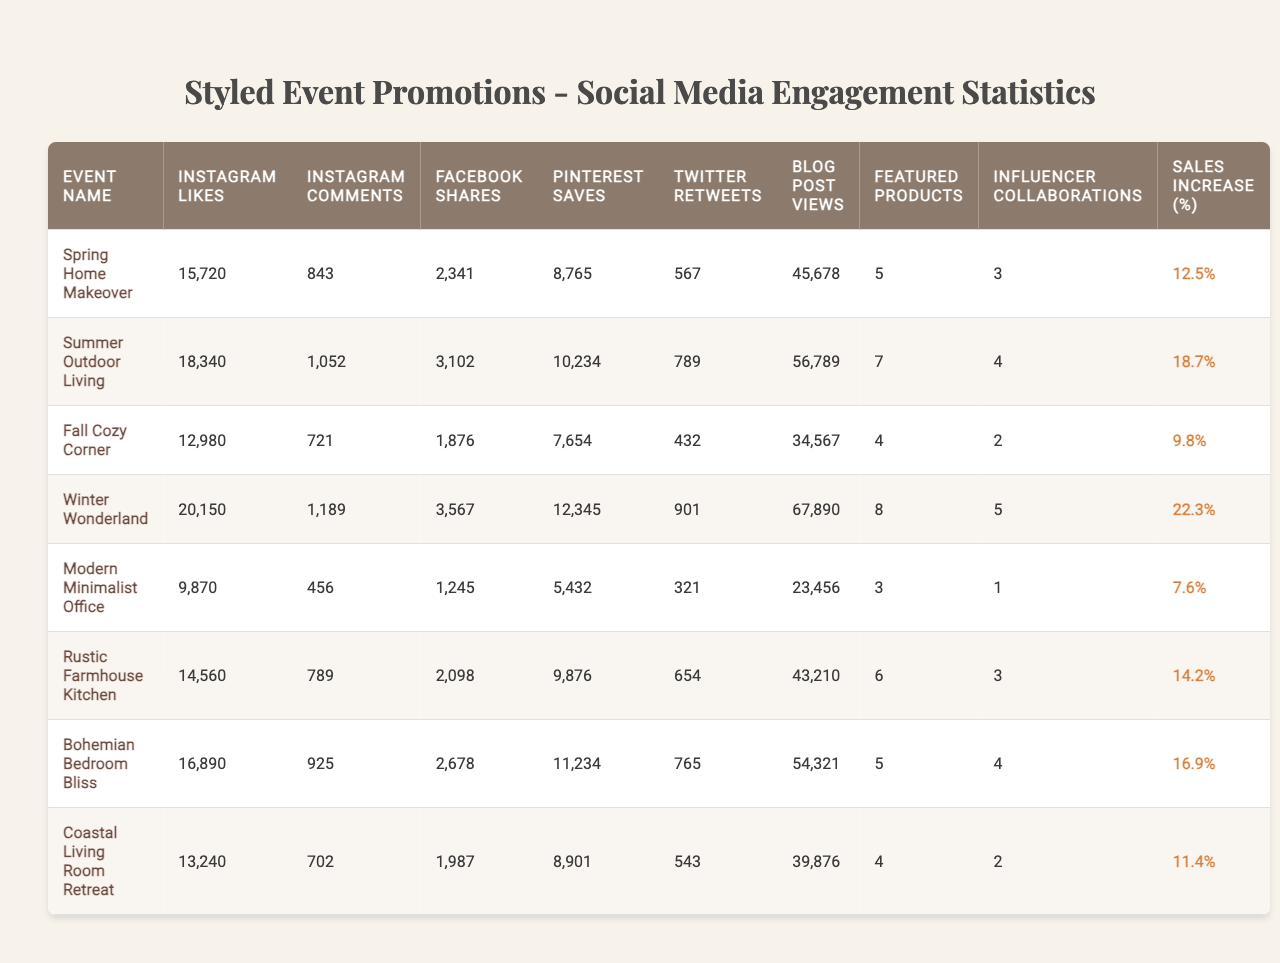What is the highest number of Instagram likes received for any event? Looking at the column for Instagram Likes, the highest value is 20150, which is for the Winter Wonderland event.
Answer: 20150 What is the total number of Facebook shares across all events? To find the total, we sum the Facebook Shares column: 2341 + 3102 + 1876 + 3567 + 1245 + 2098 + 2678 + 1987 = 19996.
Answer: 19996 Which event had the lowest number of blog post views? By checking the Blog Post Views column, the event with the lowest views is Modern Minimalist Office with 23456 views.
Answer: Modern Minimalist Office What percent increase in sales did the Fall Cozy Corner event achieve? The Sales Increase (%) for Fall Cozy Corner is 9.8%.
Answer: 9.8% Which two events had the most influencer collaborations? Looking at the Influencer Collaborations column, Summer Outdoor Living and Fall Cozy Corner both had 4 collaborations, tying for the most.
Answer: Summer Outdoor Living and Fall Cozy Corner What is the average number of Pinterest saves for the styled events? To calculate this, we add the Pinterest Saves: 8765 + 10234 + 7654 + 12345 + 5432 + 9876 + 11234 + 8901 = 70741, and then divide by the number of events, which is 8. Thus, the average is 70741 / 8 = 8842.625.
Answer: 8842.625 Was there a correlation between the number of Instagram likes and the increase in sales? To assess this, we can compare the events with higher Instagram Likes to their Sales Increase percentages. Winter Wonderland has the highest likes and a 22.3% sales increase, suggesting a positive trend, but further statistical analysis would be needed for a full conclusion.
Answer: Yes, there seems to be a positive trend What is the difference in the number of Instagram comments between the event with the highest likes and the one with the lowest? The highest likes are for Winter Wonderland with 20150 likes and 1189 comments, while the lowest is Fall Cozy Corner with 12980 likes and 721 comments. The difference is 1189 - 721 = 468 comments.
Answer: 468 Which event resulted in the least increase in sales? By looking at the Sales Increase (%) column, the event with the least increase is Modern Minimalist Office with 7.6%.
Answer: Modern Minimalist Office How many events featured more than 5 products? Reviewing the Featured Products column, the events that featured more than 5 products are Summer Outdoor Living (7), Rustic Farmhouse Kitchen (6), and Bohemian Bedroom Bliss (5). Therefore, 2 events featured more than 5 products.
Answer: 2 